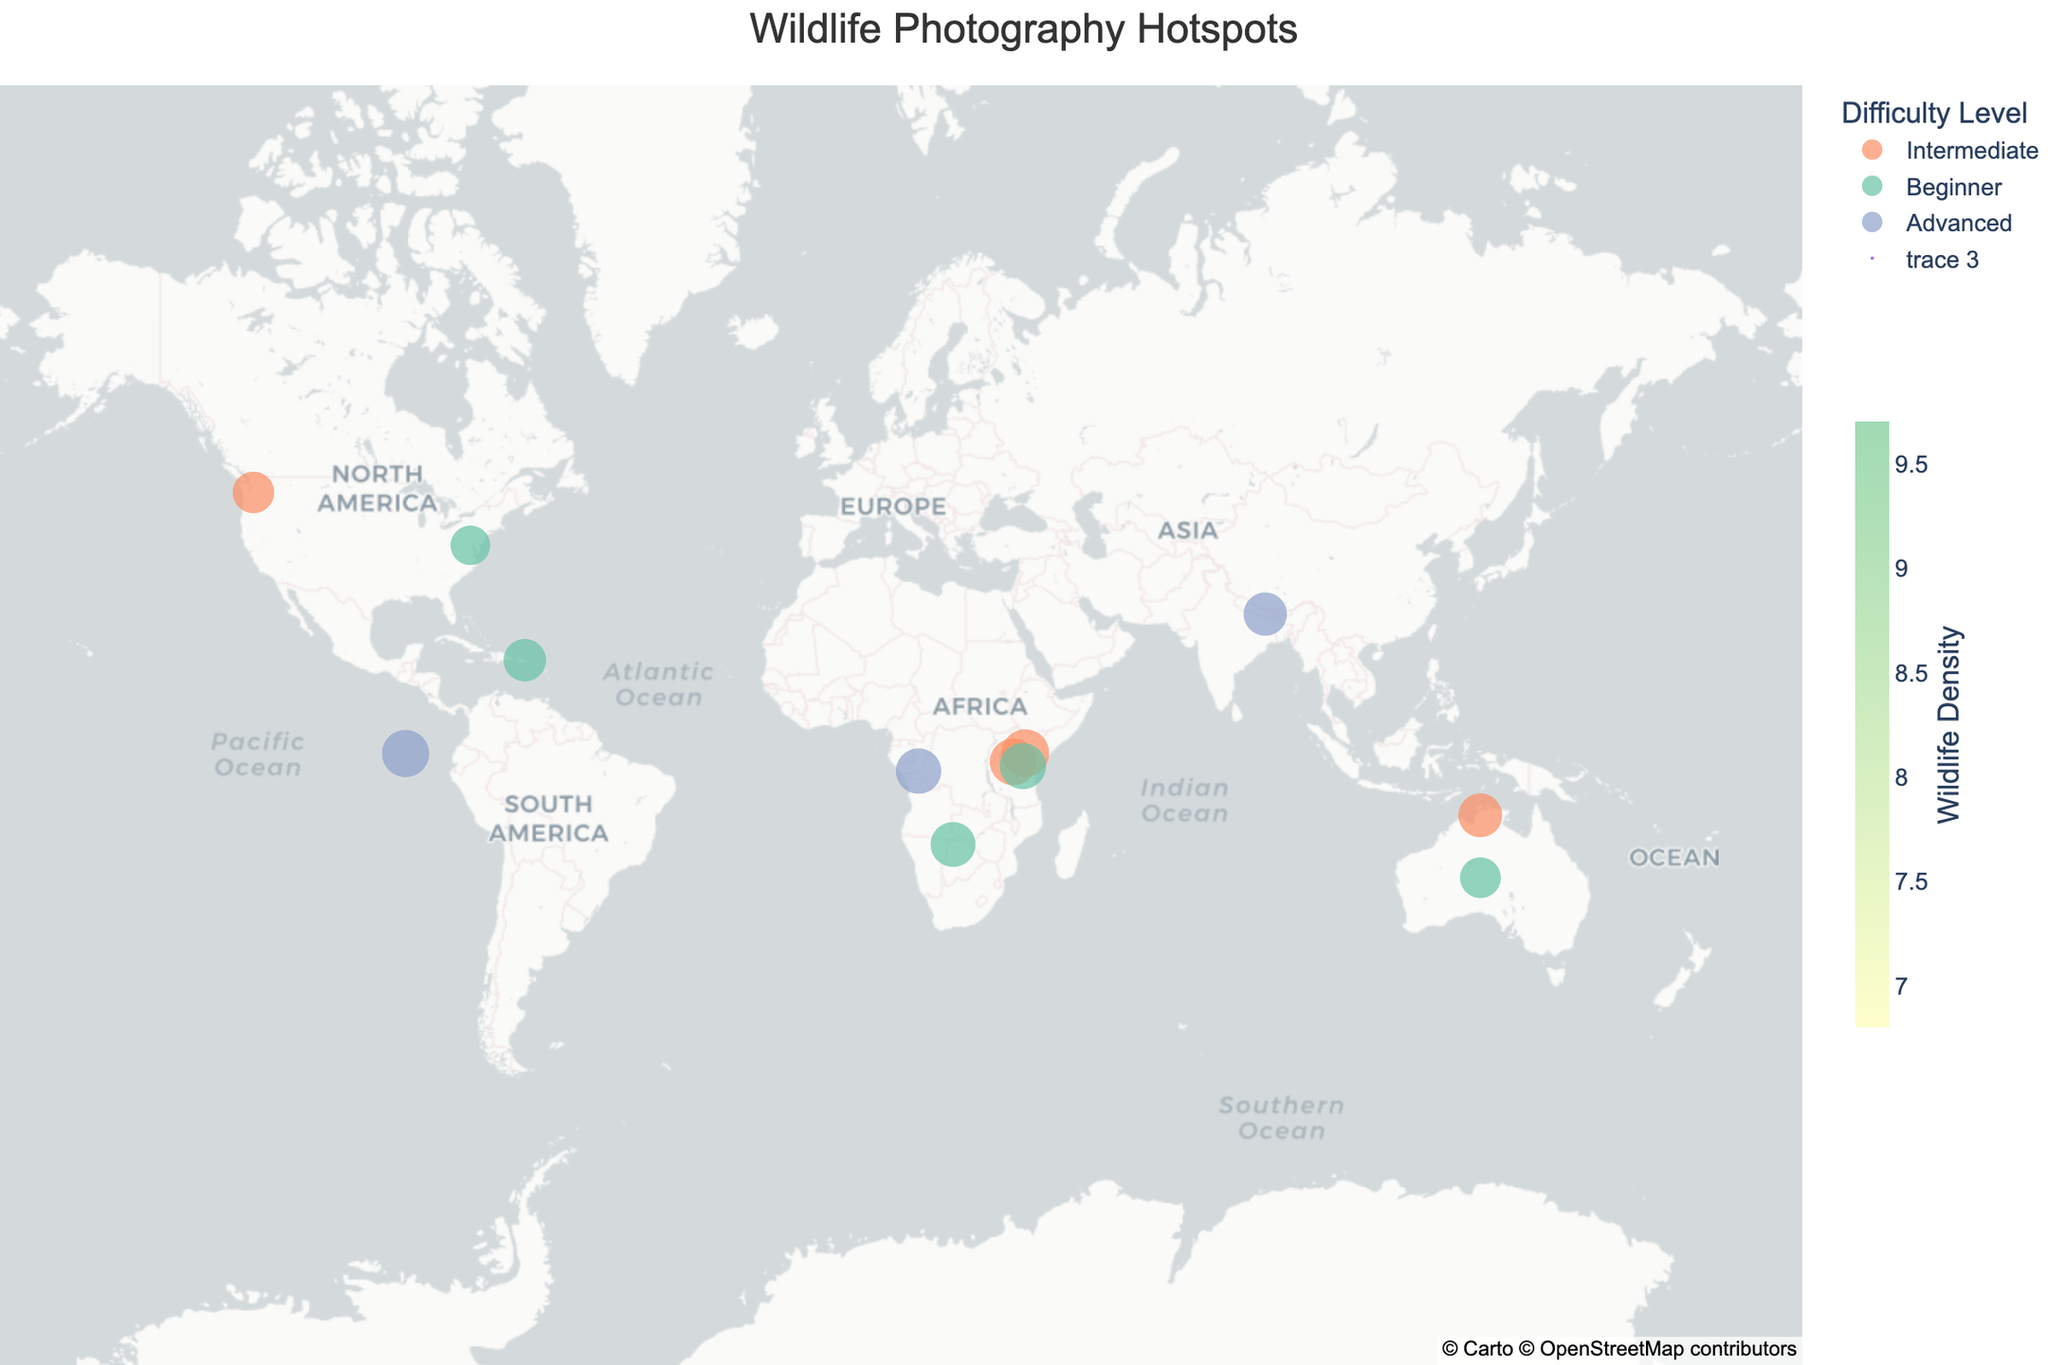What is the title of the figure? The title of the figure is shown at the top of the plot, typically centered and in a larger font size than the rest of the text.
Answer: Wildlife Photography Hotspots How many locations are indicated on the map? Count the number of scatter points on the map, each representing a different wildlife photography hotspot.
Answer: 12 Which location has the highest wildlife density? Examine the size of the scatter points, as larger points indicate higher wildlife densities. Identify the largest point and note its corresponding location.
Answer: Masai Mara National Reserve What is the best season for wildlife photography in the Galapagos Islands? Hover over or refer to the Galapagos Islands data point to see the best season for wildlife photography.
Answer: Dec-May Which locations have a difficulty level labeled as "Beginner"? Identify the points colored according to the "Beginner" color code and note their corresponding locations.
Answer: Ngorongoro Conservation Area, Chobe National Park, El Yunque National Forest, Uluru-Kata Tjuta National Park, Kenilworth Park and Aquatic Gardens How does the wildlife density in Serengeti National Park compare to Mount Rainier National Park? Compare the sizes of the scatter points for Serengeti National Park and Mount Rainier National Park. Larger points have higher wildlife densities.
Answer: Higher in Serengeti National Park Which two locations have the highest wildlife density, and what are their best seasons? Identify the two largest scatter points and note their locations and best seasons from the hover information.
Answer: Masai Mara National Reserve (Jul-Oct), Galapagos Islands (Dec-May) Of the locations marked as "Advanced" difficulty level, which one has the lowest wildlife density? Identify the scatter points marked with the "Advanced" color code and compare their sizes, noting the smallest one.
Answer: Okavango Delta What patterns do you see in the best seasons for wildlife photography in Africa? Observe the best seasons listed for the African locations and identify any common months or seasons that appear.
Answer: May-Oct is common 